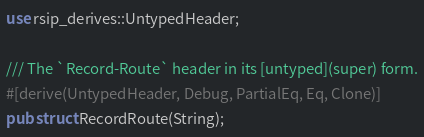<code> <loc_0><loc_0><loc_500><loc_500><_Rust_>use rsip_derives::UntypedHeader;

/// The `Record-Route` header in its [untyped](super) form.
#[derive(UntypedHeader, Debug, PartialEq, Eq, Clone)]
pub struct RecordRoute(String);
</code> 